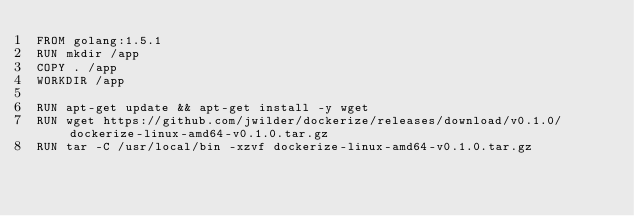<code> <loc_0><loc_0><loc_500><loc_500><_Dockerfile_>FROM golang:1.5.1
RUN mkdir /app
COPY . /app
WORKDIR /app

RUN apt-get update && apt-get install -y wget
RUN wget https://github.com/jwilder/dockerize/releases/download/v0.1.0/dockerize-linux-amd64-v0.1.0.tar.gz
RUN tar -C /usr/local/bin -xzvf dockerize-linux-amd64-v0.1.0.tar.gz
</code> 